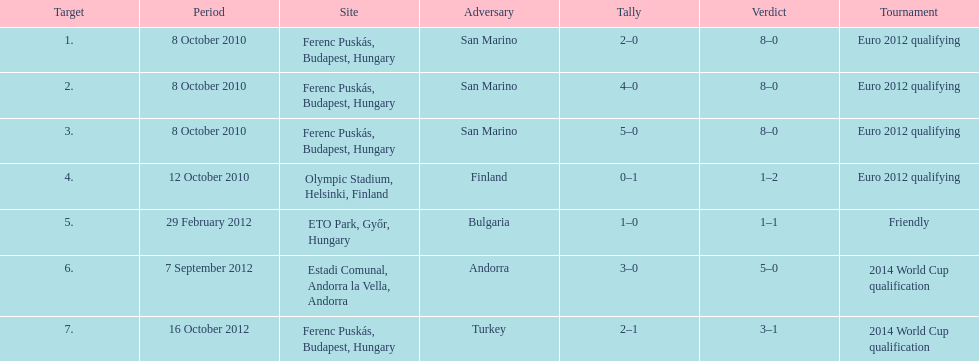How many goals were netted in the euro 2012 qualifying contest? 12. 